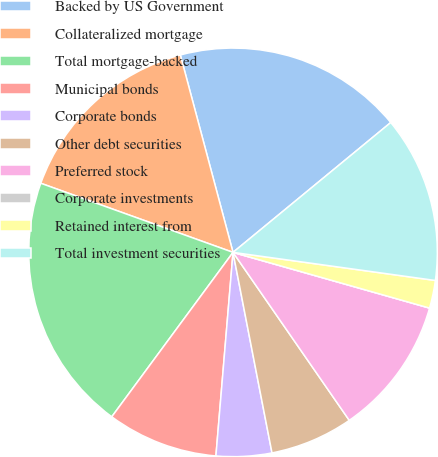Convert chart. <chart><loc_0><loc_0><loc_500><loc_500><pie_chart><fcel>Backed by US Government<fcel>Collateralized mortgage<fcel>Total mortgage-backed<fcel>Municipal bonds<fcel>Corporate bonds<fcel>Other debt securities<fcel>Preferred stock<fcel>Corporate investments<fcel>Retained interest from<fcel>Total investment securities<nl><fcel>18.19%<fcel>15.36%<fcel>20.38%<fcel>8.78%<fcel>4.39%<fcel>6.58%<fcel>10.97%<fcel>0.0%<fcel>2.2%<fcel>13.16%<nl></chart> 